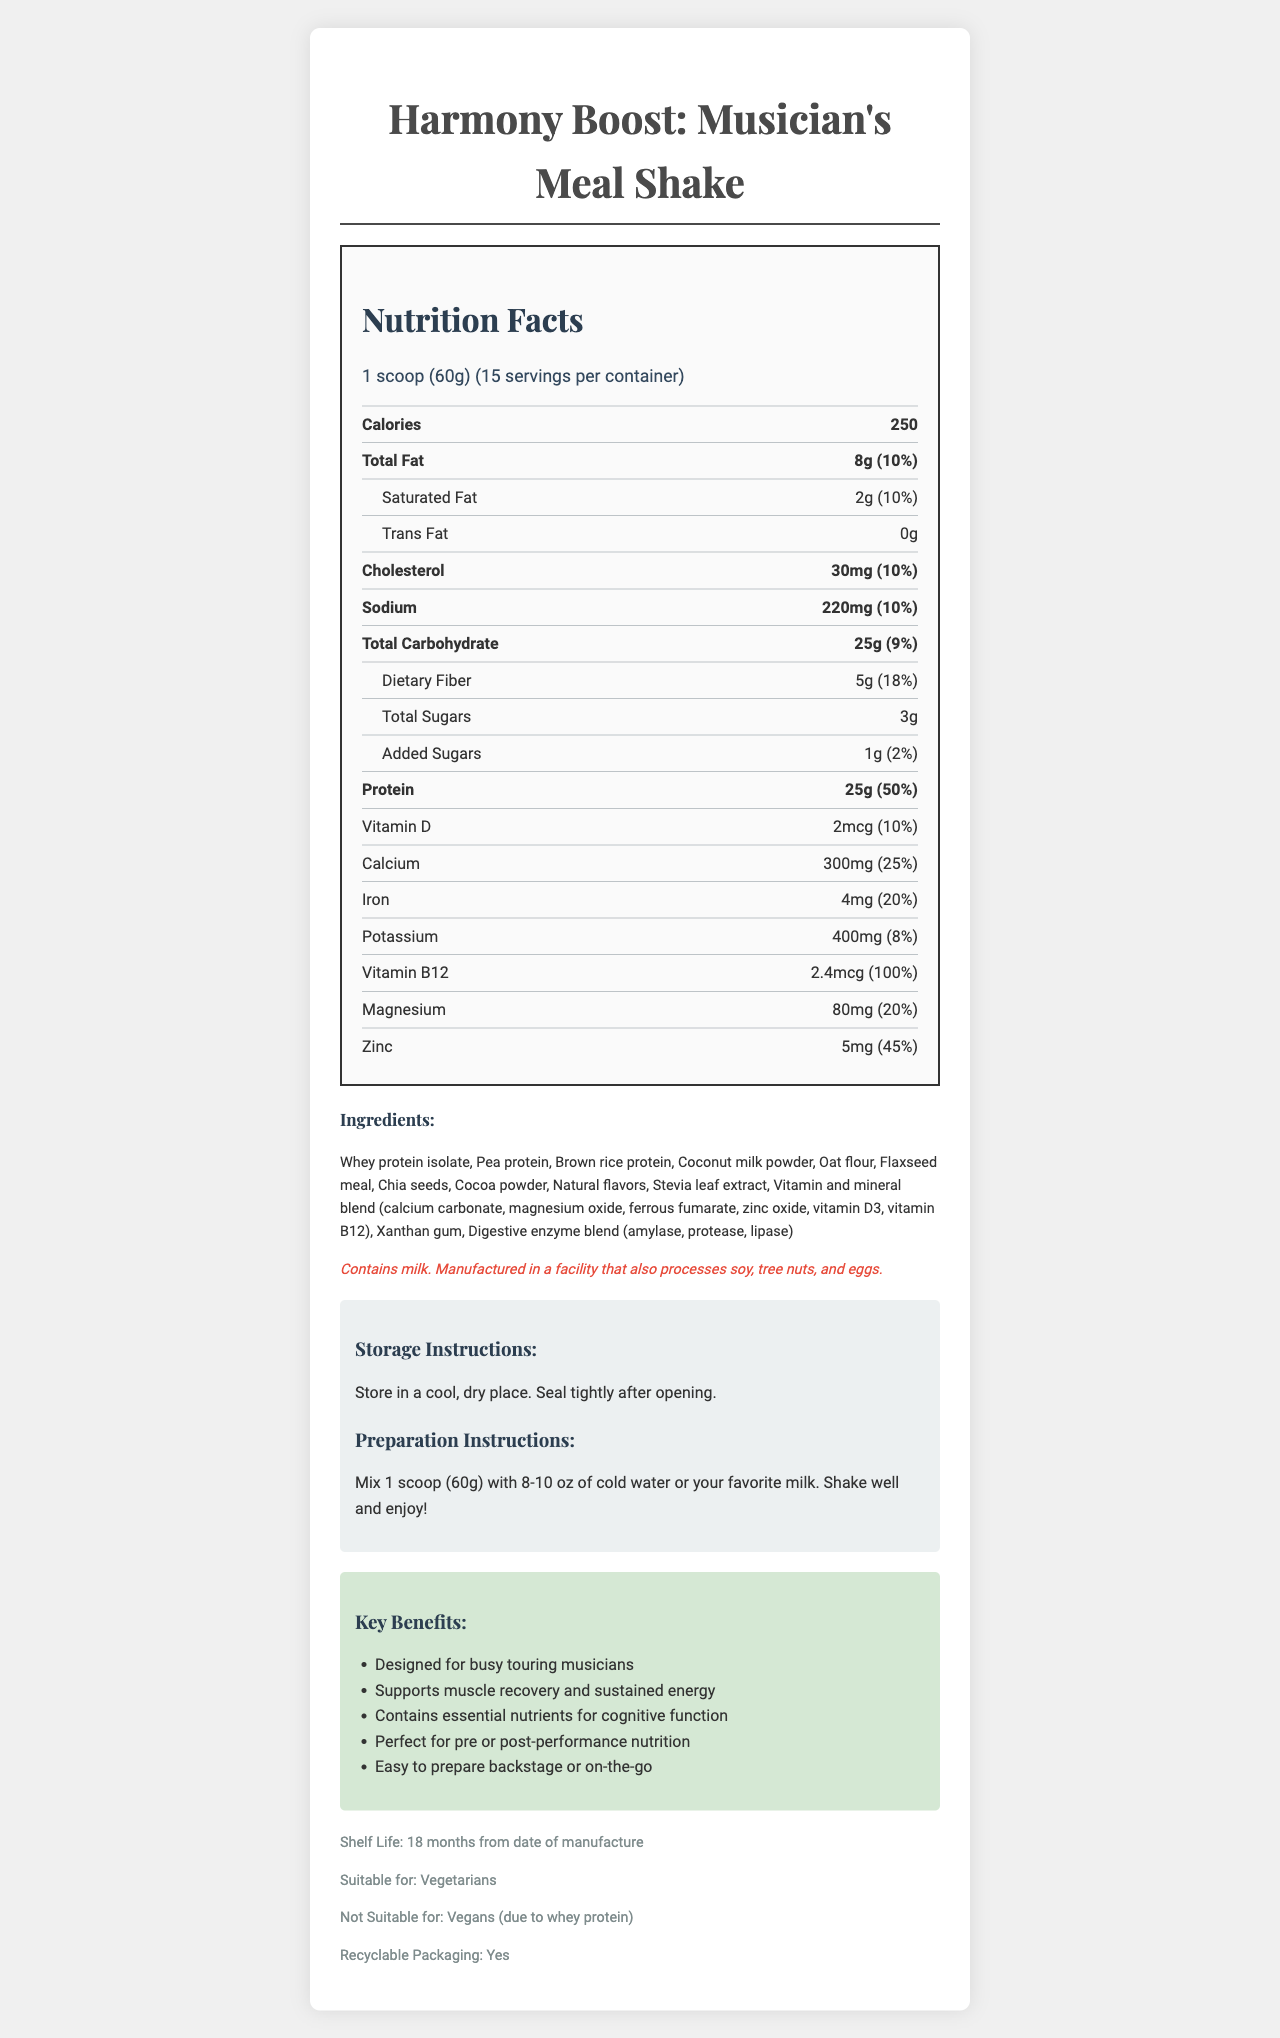who is the target audience for this product? The document mentions multiple times that the shake is designed for busy touring musicians, in both the product name and marketing claims.
Answer: Busy touring musicians how many grams of protein are in one serving? Under the Nutrition Facts, the document states that there are 25g of protein per serving.
Answer: 25g total carbohydrate content in percentage of daily value? The Nutrition Facts section lists the total carbohydrate content as 25g, which is 9% of the daily value.
Answer: 9% what are the preparation instructions for the shake? The preparation instructions are clearly mentioned under the instructions section.
Answer: Mix 1 scoop (60g) with 8-10 oz of cold water or your favorite milk. Shake well and enjoy! what essential nutrient has the highest percentage of daily value? Vitamin B12 has a daily value percentage of 100%, which is the highest listed.
Answer: Vitamin B12 how many servings are there per container? The document specifies that there are 15 servings per container in the serving info section.
Answer: 15 which ingredient is not suitable for vegans? The additional info section mentions that the product is not suitable for vegans due to whey protein.
Answer: Whey protein isolate which of the following is NOT an ingredient in the product? A. Flaxseed meal B. Chia seeds C. Almond milk D. Oat flour The ingredients list does not include almond milk.
Answer: C which of these key benefits is mentioned? A. Supports muscle recovery and sustained energy B. Improves skin health C. Enhances visual acuity 'Supports muscle recovery and sustained energy' is listed under the key benefits section.
Answer: A which vitamin is present in the smallest amount? A. Vitamin D B. Calcium C. Iron The document lists Vitamin D as 2mcg, which is the smallest amount compared to calcium and iron.
Answer: A Does the product contain any added sugars? The Nutrition Facts section shows that there is 1g of added sugars.
Answer: Yes is the packaging recyclable? The additional information section states that the packaging is recyclable.
Answer: Yes summarize the entire document This summary encapsulates the key points and structure of the document, including its target audience, main nutritional features, ingredient list, and additional claims and instructions.
Answer: The document provides detailed information about "Harmony Boost: Musician's Meal Shake," emphasizing its design for busy touring musicians. It includes Nutrition Facts, ingredients with allergen information, preparation and storage instructions, marketing claims about the benefits for musicians, and additional information like shelf life and suitability for vegetarians. The document highlights that the shake is a protein-packed meal replacement, containing essential nutrients that support muscle recovery, sustained energy, and cognitive function, while being easy to prepare on the go. What is the price of the product? The document does not mention the price of the product at all, so it cannot be determined.
Answer: Not enough information 